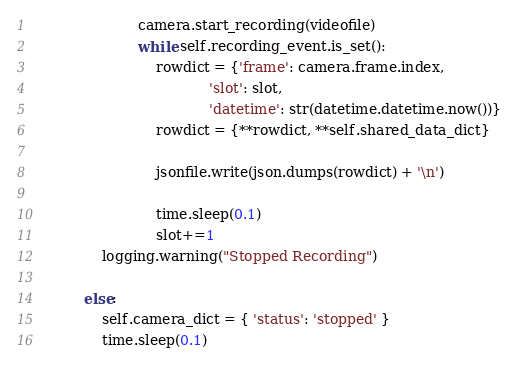Convert code to text. <code><loc_0><loc_0><loc_500><loc_500><_Python_>                        camera.start_recording(videofile)
                        while self.recording_event.is_set():
                            rowdict = {'frame': camera.frame.index,
                                        'slot': slot,
                                        'datetime': str(datetime.datetime.now())}
                            rowdict = {**rowdict, **self.shared_data_dict}

                            jsonfile.write(json.dumps(rowdict) + '\n')

                            time.sleep(0.1)
                            slot+=1
                logging.warning("Stopped Recording")

            else:
                self.camera_dict = { 'status': 'stopped' }
                time.sleep(0.1)
</code> 